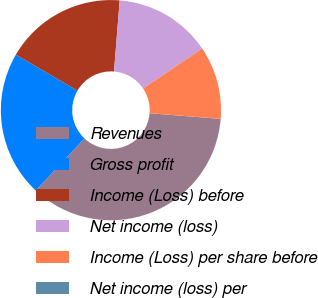<chart> <loc_0><loc_0><loc_500><loc_500><pie_chart><fcel>Revenues<fcel>Gross profit<fcel>Income (Loss) before<fcel>Net income (loss)<fcel>Income (Loss) per share before<fcel>Net income (loss) per<nl><fcel>35.71%<fcel>21.43%<fcel>17.86%<fcel>14.29%<fcel>10.71%<fcel>0.0%<nl></chart> 